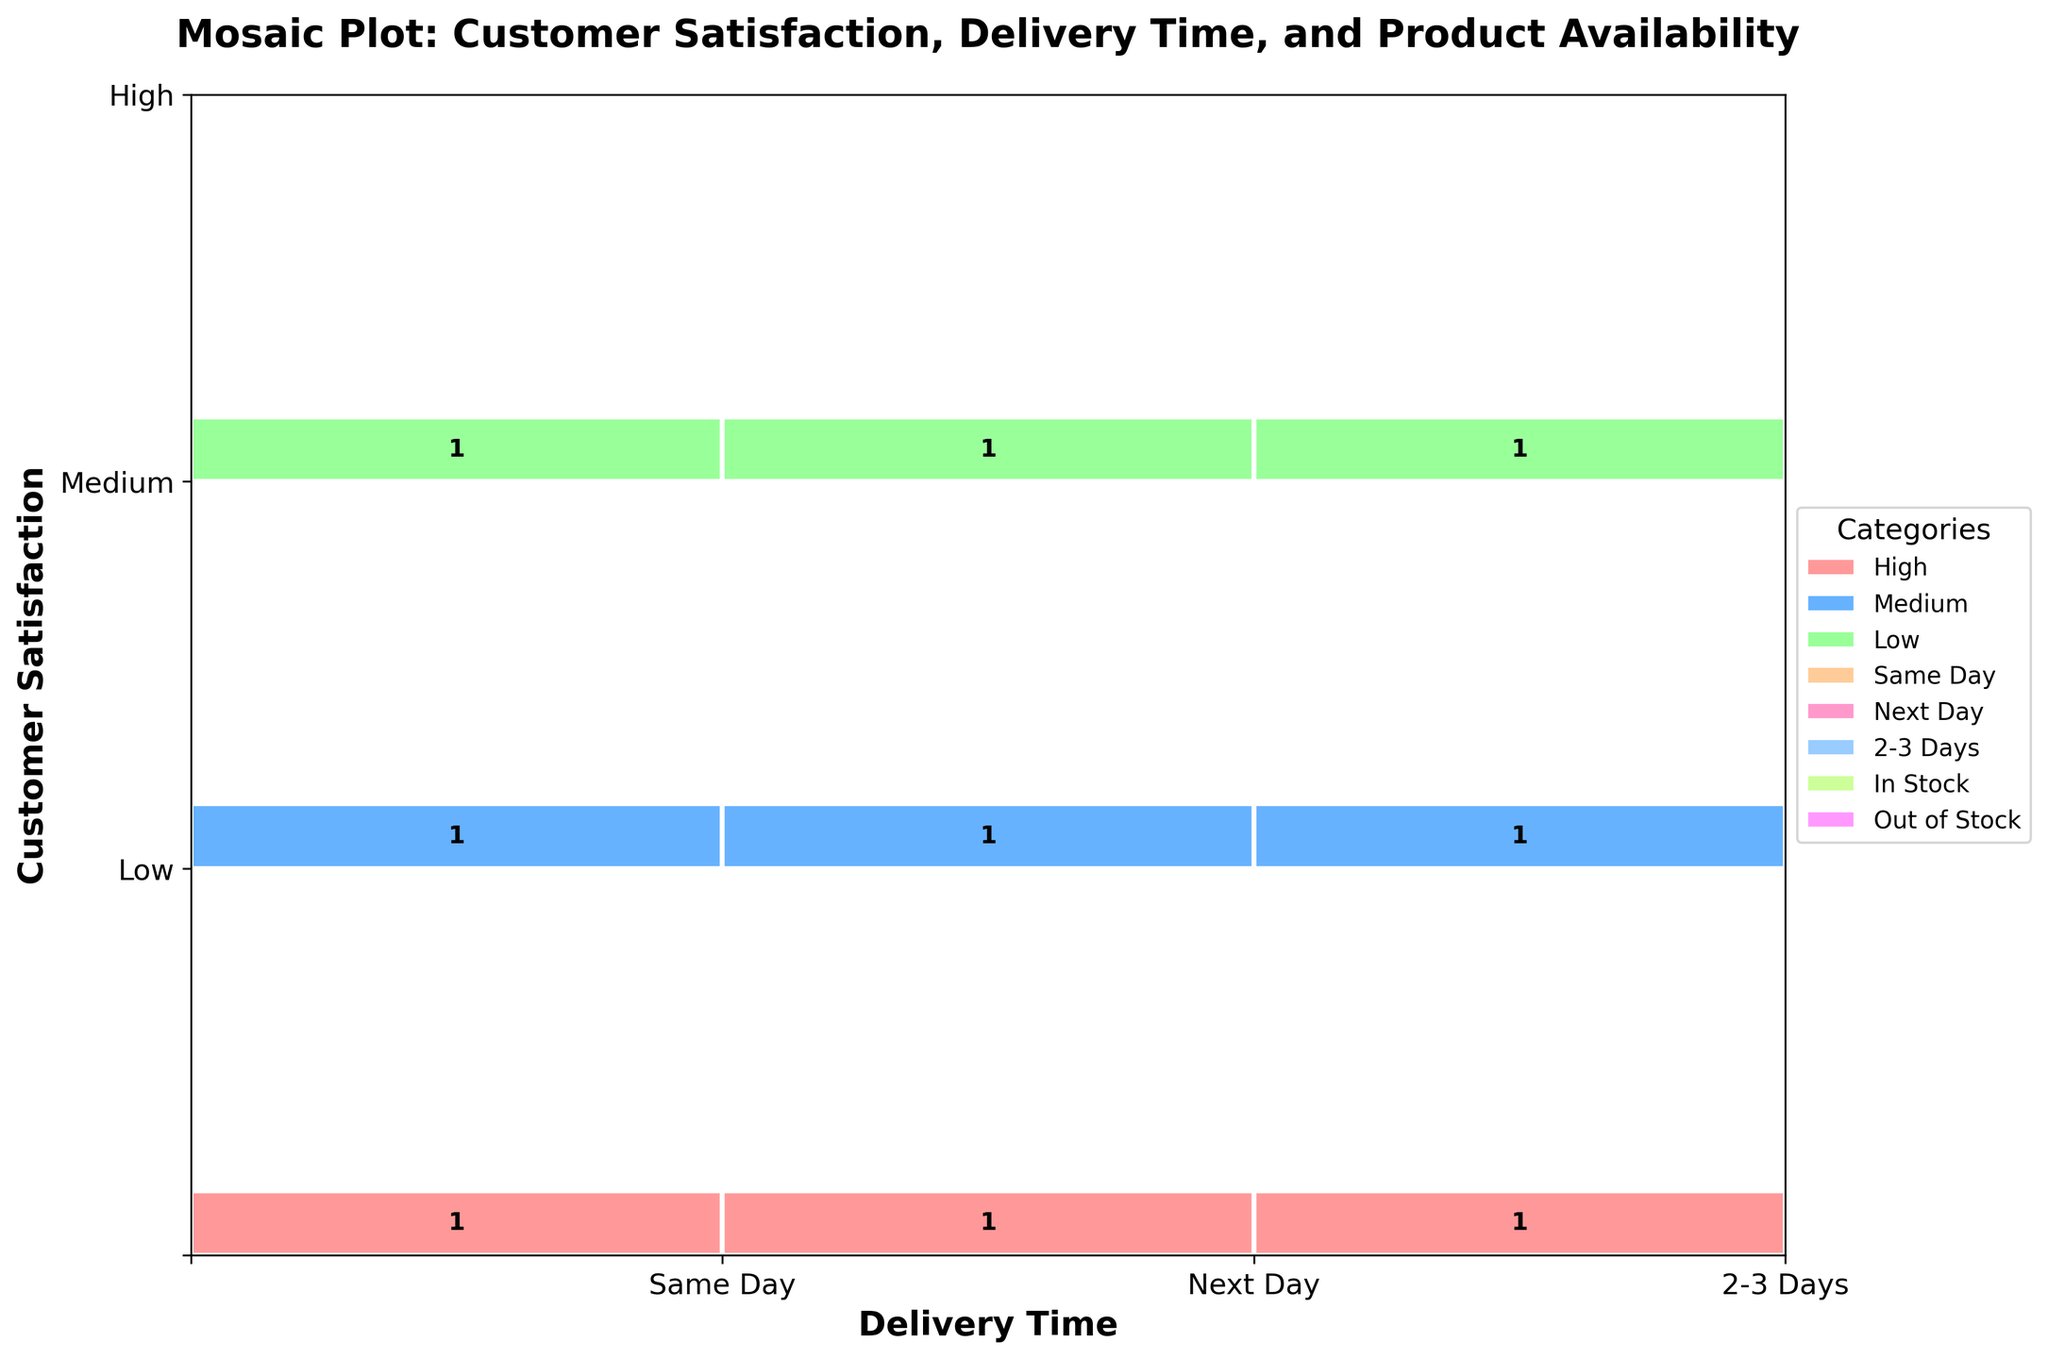How many rectangles are there in the plot? The plot shows three main categories: Customer Satisfaction, Delivery Time, and Product Availability. There are 6 combinations of Delivery Time and Product Availability (3 delivery times × 2 product availabilities), and for each of these combinations, there are 3 levels of satisfaction. Therefore, there are 3 × 6 = 18 rectangles.
Answer: 18 What color indicates high customer satisfaction? The legend on the right side of the plot shows that 'High' customer satisfaction is indicated by the color red.
Answer: Red Which delivery time category is the largest? The x-axis includes ticks for 'Same Day', 'Next Day', and '2-3 Days' delivery times. The width of the x-segments corresponding to each category shows that 'Same Day' has the largest width, indicating that it is the largest category.
Answer: Same Day In terms of customer satisfaction, which category is the smallest? The y-axis includes ticks for 'Low', 'Medium', and 'High' satisfaction. The height of the y-segments corresponding to each category shows that 'Low' has the smallest height, indicating that it is the smallest category.
Answer: Low How often is the delivery time 'Next Day' combined with 'Out of Stock' products? Find the segment on the x-axis labeled 'Next Day', then look at the 'Out of Stock' segments within this category. Count the number within the relevant rectangle. This number is annotated on the plot.
Answer: 2 What is the most frequent combination of 'Delivery Time' and 'Product Availability' for high customer satisfaction? Focusing on the highest customer satisfaction 'High' color, observe the counts for each pair of delivery time and product availability. Next, identify the largest number annotated within 'Same Day' or 'In Stock'. This guides which combination is most frequent.
Answer: Same Day and In Stock Which combination of customer satisfaction and delivery time is more common for 'In Stock' products, 'High' or 'Medium'? Compare the counts of rectangles that represent 'In Stock' products for 'High' and 'Medium' satisfaction across all delivery times. Summing these counts will show which combination appears more frequently.
Answer: High How many 'Low' satisfaction ratings occur with 'Next Day' deliveries? Find the 'Low' customer satisfaction row, and then look for rectangles under the 'Next Day' delivery time. Sum the annotations within these rectangles for 'In Stock' and 'Out of Stock'. The total is the number of 'Low' satisfaction ratings for 'Next Day'.
Answer: 4 Are there more products 'In Stock' or 'Out of Stock' for 'Medium' customer satisfaction? Compare the number of annotations within the 'Medium' customer satisfaction category for both 'In Stock' and 'Out of Stock' rectangles. The greater sum represents which condition is more frequent.
Answer: In Stock 